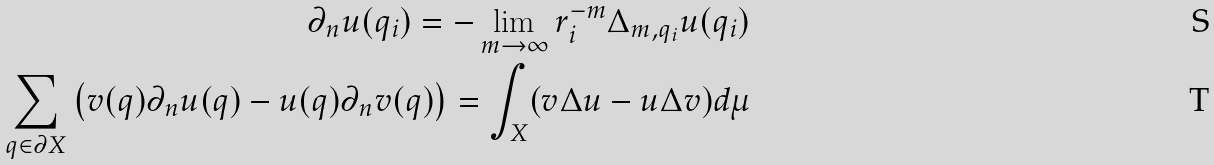<formula> <loc_0><loc_0><loc_500><loc_500>\partial _ { n } u ( q _ { i } ) = - \lim _ { m \rightarrow \infty } r _ { i } ^ { - m } \Delta _ { m , q _ { i } } u ( q _ { i } ) \\ \sum _ { q \in \partial X } \left ( v ( q ) \partial _ { n } u ( q ) - u ( q ) \partial _ { n } v ( q ) \right ) = \int _ { X } ( v \Delta u - u \Delta v ) d \mu</formula> 